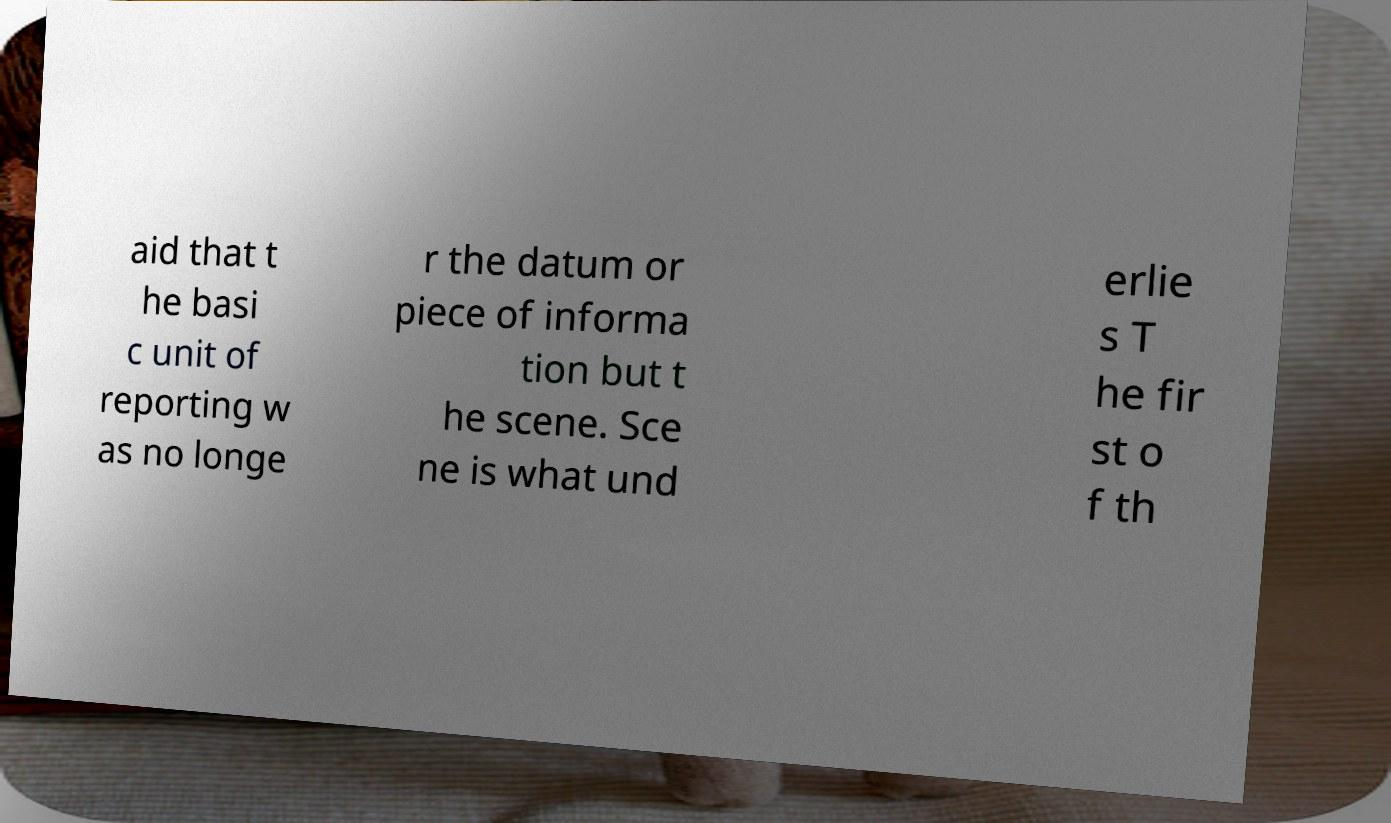There's text embedded in this image that I need extracted. Can you transcribe it verbatim? aid that t he basi c unit of reporting w as no longe r the datum or piece of informa tion but t he scene. Sce ne is what und erlie s T he fir st o f th 